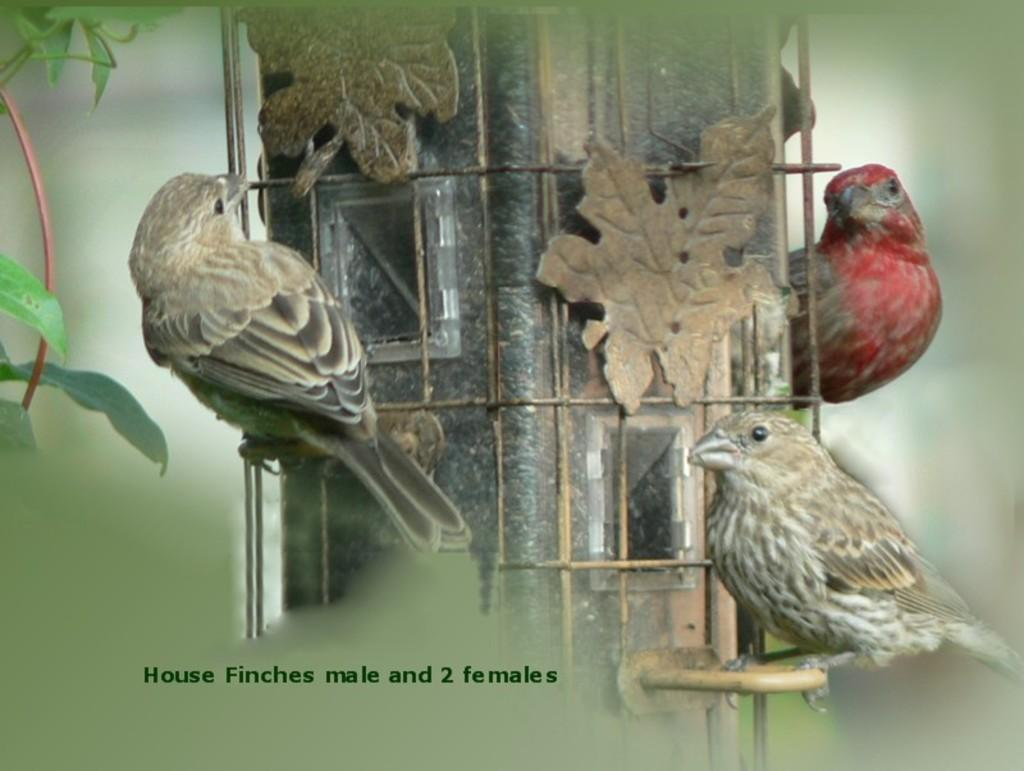What is the main subject in the center of the image? There are birds in the center of the image. What can be seen on the left side of the image? There are leaves on the left side of the image. What type of competition is taking place in the image? There is no competition present in the image; it features birds and leaves. What type of canvas is used to create the image? The image is not a painting, so there is no canvas involved in its creation. 